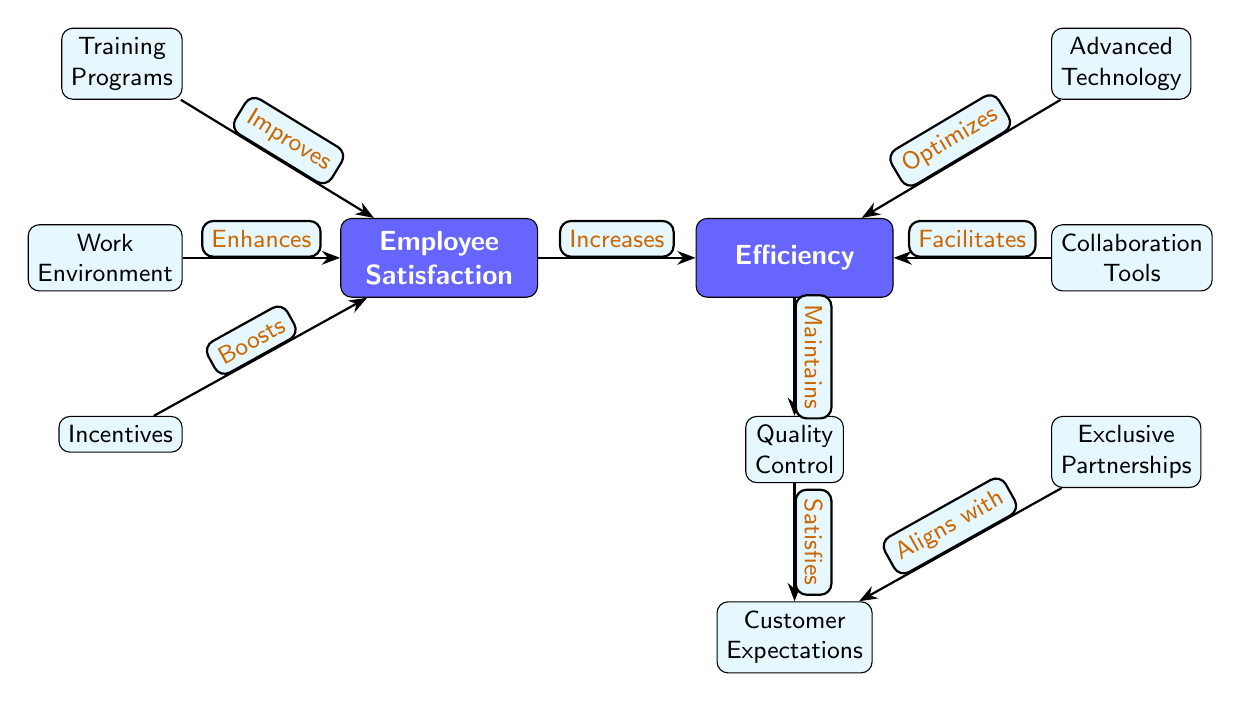What is the relationship between Training Programs and Employee Satisfaction? The diagram indicates that Training Programs "Improves" Employee Satisfaction. The direction of the edge from Training Programs to Employee Satisfaction reflects this direct improvement relationship.
Answer: Improves How many nodes are present in this diagram? By counting each distinct box or label in the diagram, including the main concepts and supporting elements, we find a total of 8 nodes connected by edges.
Answer: 8 Which node is positioned below Quality Control? The diagram shows that Customer Expectations is directly positioned below Quality Control, forming a hierarchical relationship where Quality Control impacts Customer Expectations.
Answer: Customer Expectations What effect does Work Environment have on Employee Satisfaction? The diagram states that Work Environment "Enhances" Employee Satisfaction, indicating a positive contribution or improvement relationship. The edge points from Work Environment to Employee Satisfaction.
Answer: Enhances How does Exclusive Partnerships relate to Customer Expectations? According to the diagram, Exclusive Partnerships "Aligns with" Customer Expectations. This implies a strong connection where the nature of exclusive partnerships corresponds directly with meeting customer expectations.
Answer: Aligns with What is the outcome of Employee Satisfaction on Efficiency? The relationship depicted in the diagram illustrates that Employee Satisfaction "Increases" Efficiency, meaning improvements or boosts in employee satisfaction positively affect overall efficiency in the tech manufacturing process.
Answer: Increases What is the role of Advanced Technology in terms of Efficiency? The diagram specifies that Advanced Technology "Optimizes" Efficiency, indicating its critical role in enhancing the operational effectiveness within the manufacturing context.
Answer: Optimizes How do Incentives impact Employee Satisfaction? The diagram illustrates that Incentives "Boosts" Employee Satisfaction. This shows that providing incentives is a strategy employed to enhance how satisfied employees feel in their work environment.
Answer: Boosts What does Collaboration Tools facilitate? The diagram indicates that Collaboration Tools "Facilitates" Efficiency, highlighting its importance in streamlining processes and communications that contribute to higher operational effectiveness.
Answer: Facilitates 